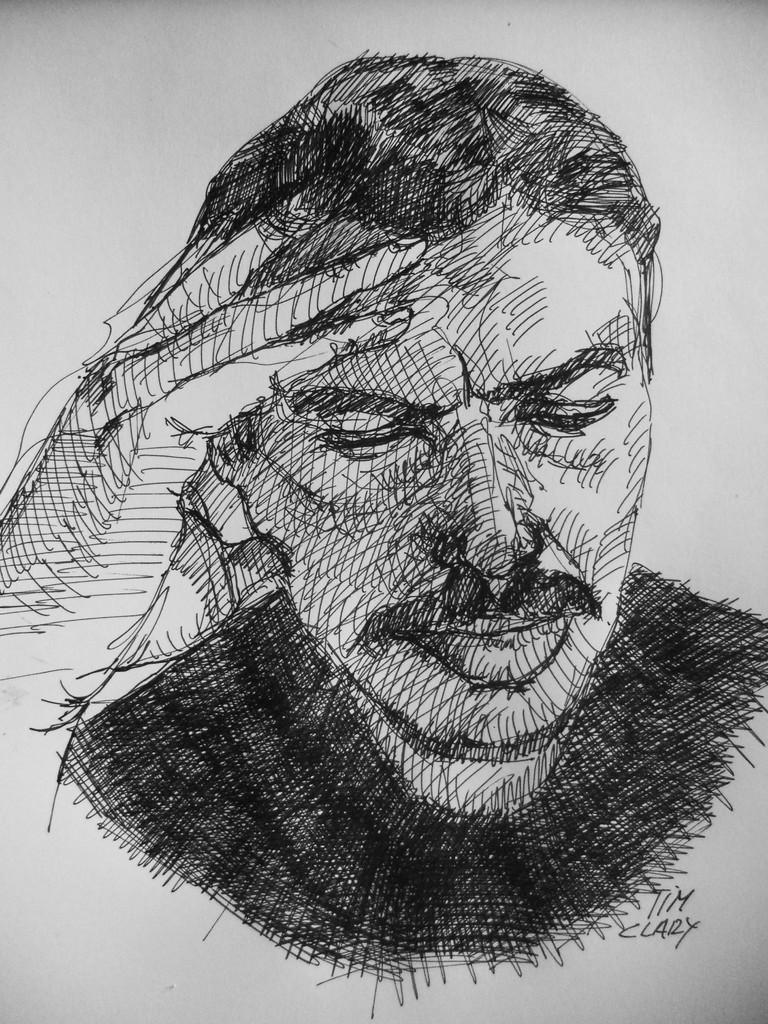What is the main subject of the picture? The main subject of the picture is a drawing of a man. What is the man in the drawing doing? The man is depicted with his hand on his head. How many crooks are present in the drawing? There are no crooks depicted in the drawing; it features a man with his hand on his head. What type of bears can be seen interacting with the man in the drawing? There are no bears present in the drawing; it features a man with his hand on his head. 